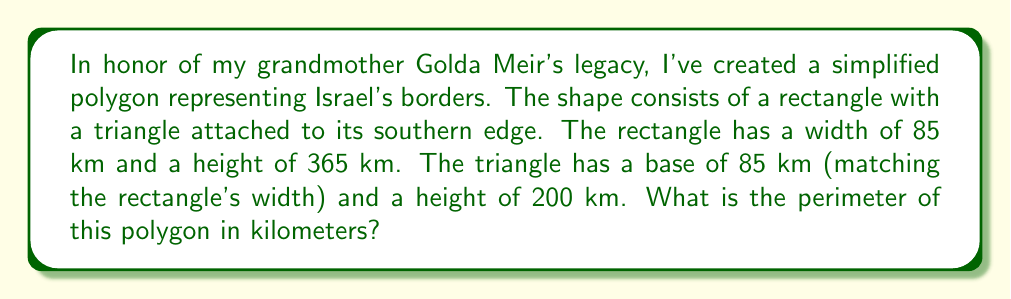Provide a solution to this math problem. Let's approach this step-by-step:

1) First, we need to calculate the perimeter of the rectangle:
   - Width of rectangle: $w = 85$ km
   - Height of rectangle: $h = 365$ km
   - Perimeter of rectangle: $P_r = 2(w + h) = 2(85 + 365) = 2(450) = 900$ km

2) Next, we need to calculate the length of the two sides of the triangle:
   - Base of triangle: $b = 85$ km (same as rectangle width)
   - Height of triangle: $a = 200$ km
   - Using the Pythagorean theorem to find the length of one side:
     $s = \sqrt{(\frac{b}{2})^2 + a^2} = \sqrt{(42.5)^2 + 200^2} = \sqrt{1806.25 + 40000} = \sqrt{41806.25} \approx 204.47$ km

3) The perimeter of the polygon is the perimeter of the rectangle minus the base of the triangle (as it's shared), plus the two sides of the triangle:
   $P = P_r - b + 2s = 900 - 85 + 2(204.47) = 1223.94$ km

[asy]
unitsize(0.5mm);
fill((0,0)--(85,0)--(85,365)--(0,365)--cycle,lightgray);
fill((0,0)--(85,0)--(42.5,-200)--cycle,lightgray);
draw((0,0)--(85,0)--(85,365)--(0,365)--cycle);
draw((0,0)--(85,0)--(42.5,-200)--cycle);
label("365 km", (90,182.5), E);
label("85 km", (42.5,5), S);
label("200 km", (50,-100), E);
[/asy]
Answer: $1223.94$ km 